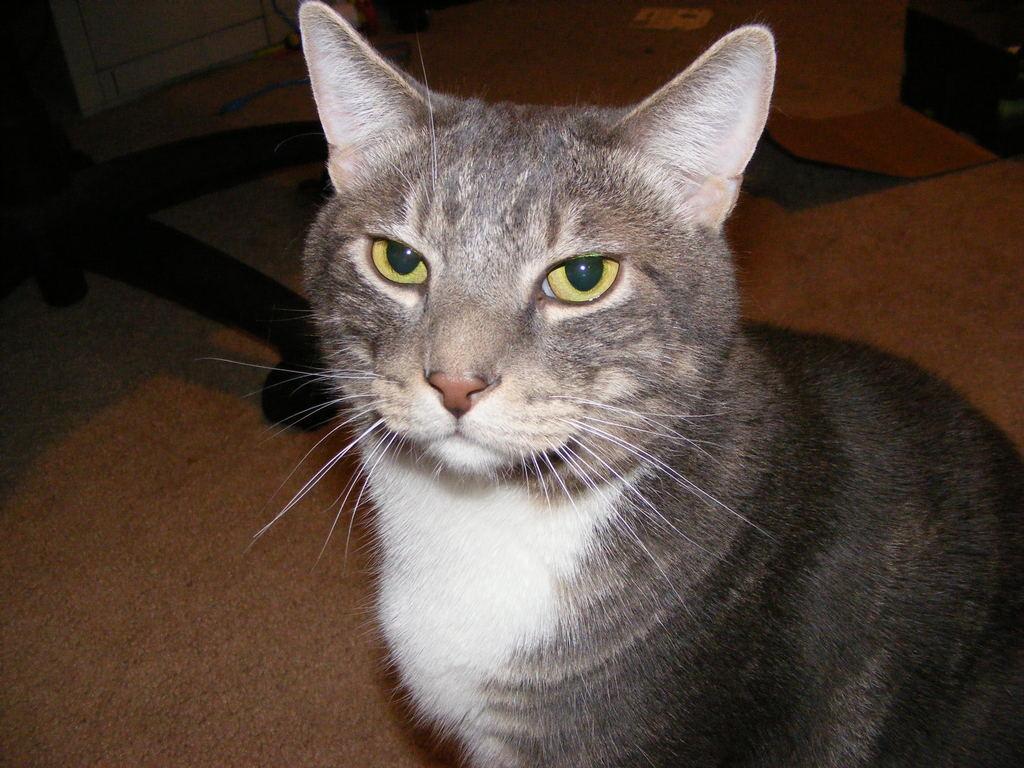Can you describe this image briefly? In the image we can see the close up picture of the cat on the right side of the image. Here we can see the chair and the floor. 